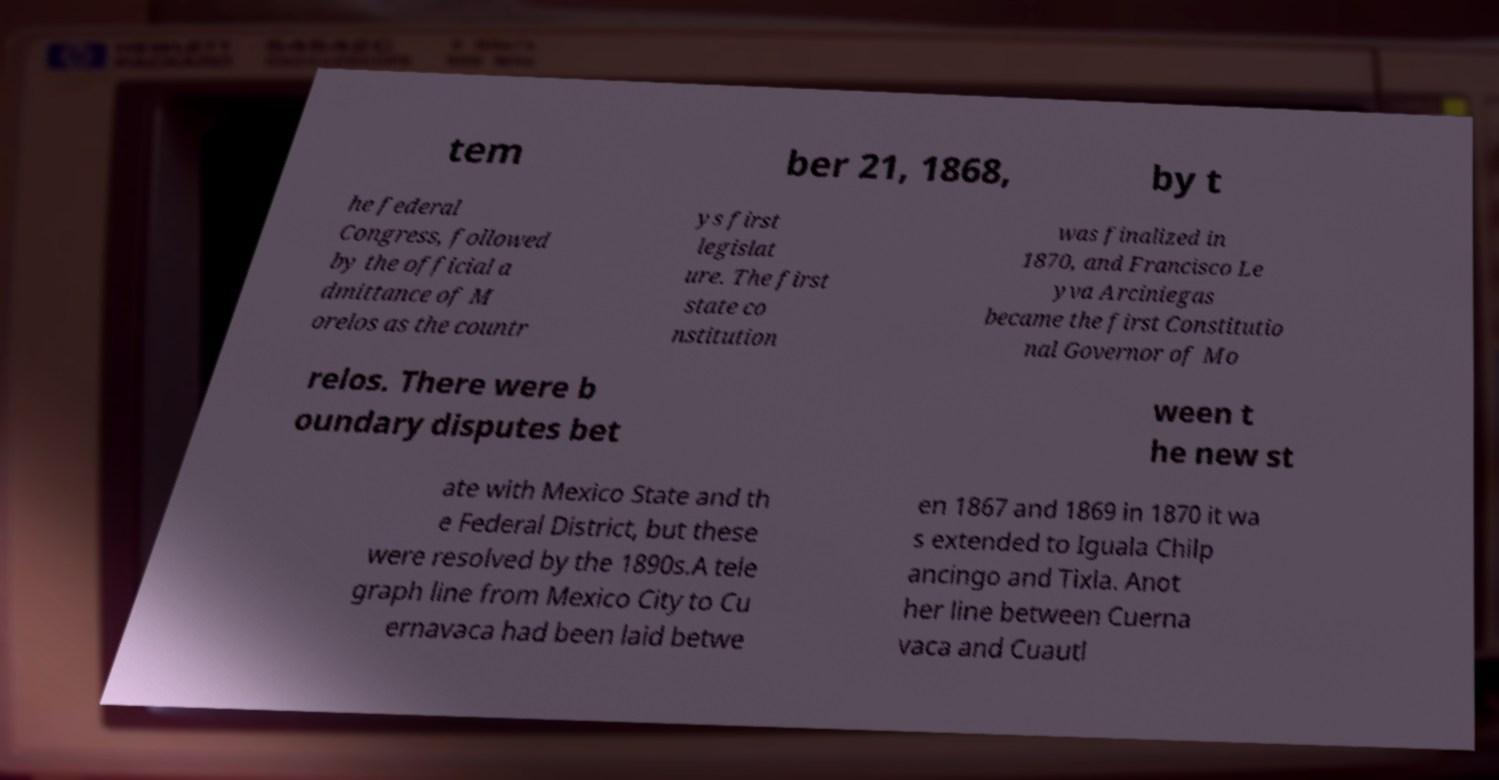Could you assist in decoding the text presented in this image and type it out clearly? tem ber 21, 1868, by t he federal Congress, followed by the official a dmittance of M orelos as the countr ys first legislat ure. The first state co nstitution was finalized in 1870, and Francisco Le yva Arciniegas became the first Constitutio nal Governor of Mo relos. There were b oundary disputes bet ween t he new st ate with Mexico State and th e Federal District, but these were resolved by the 1890s.A tele graph line from Mexico City to Cu ernavaca had been laid betwe en 1867 and 1869 in 1870 it wa s extended to Iguala Chilp ancingo and Tixla. Anot her line between Cuerna vaca and Cuautl 